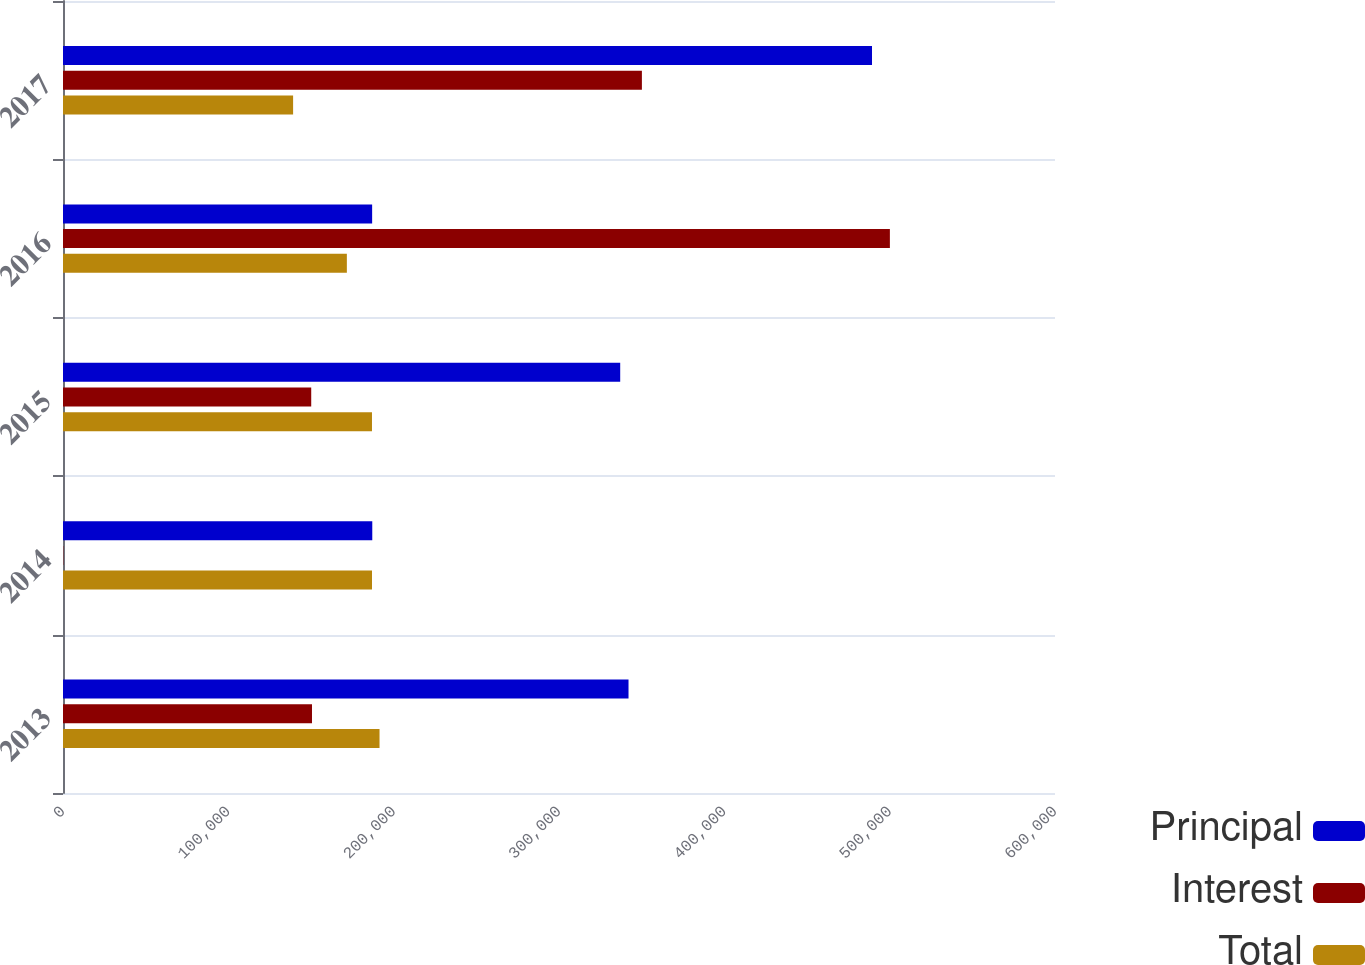Convert chart to OTSL. <chart><loc_0><loc_0><loc_500><loc_500><stacked_bar_chart><ecel><fcel>2013<fcel>2014<fcel>2015<fcel>2016<fcel>2017<nl><fcel>Principal<fcel>342050<fcel>187063<fcel>337019<fcel>186978<fcel>489317<nl><fcel>Interest<fcel>150602<fcel>170<fcel>150137<fcel>500130<fcel>350138<nl><fcel>Total<fcel>191448<fcel>186893<fcel>186882<fcel>171687<fcel>139179<nl></chart> 